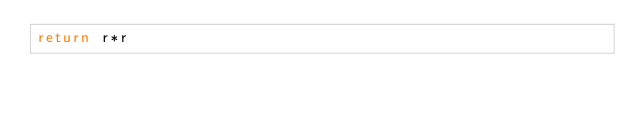<code> <loc_0><loc_0><loc_500><loc_500><_JavaScript_>return r*r</code> 